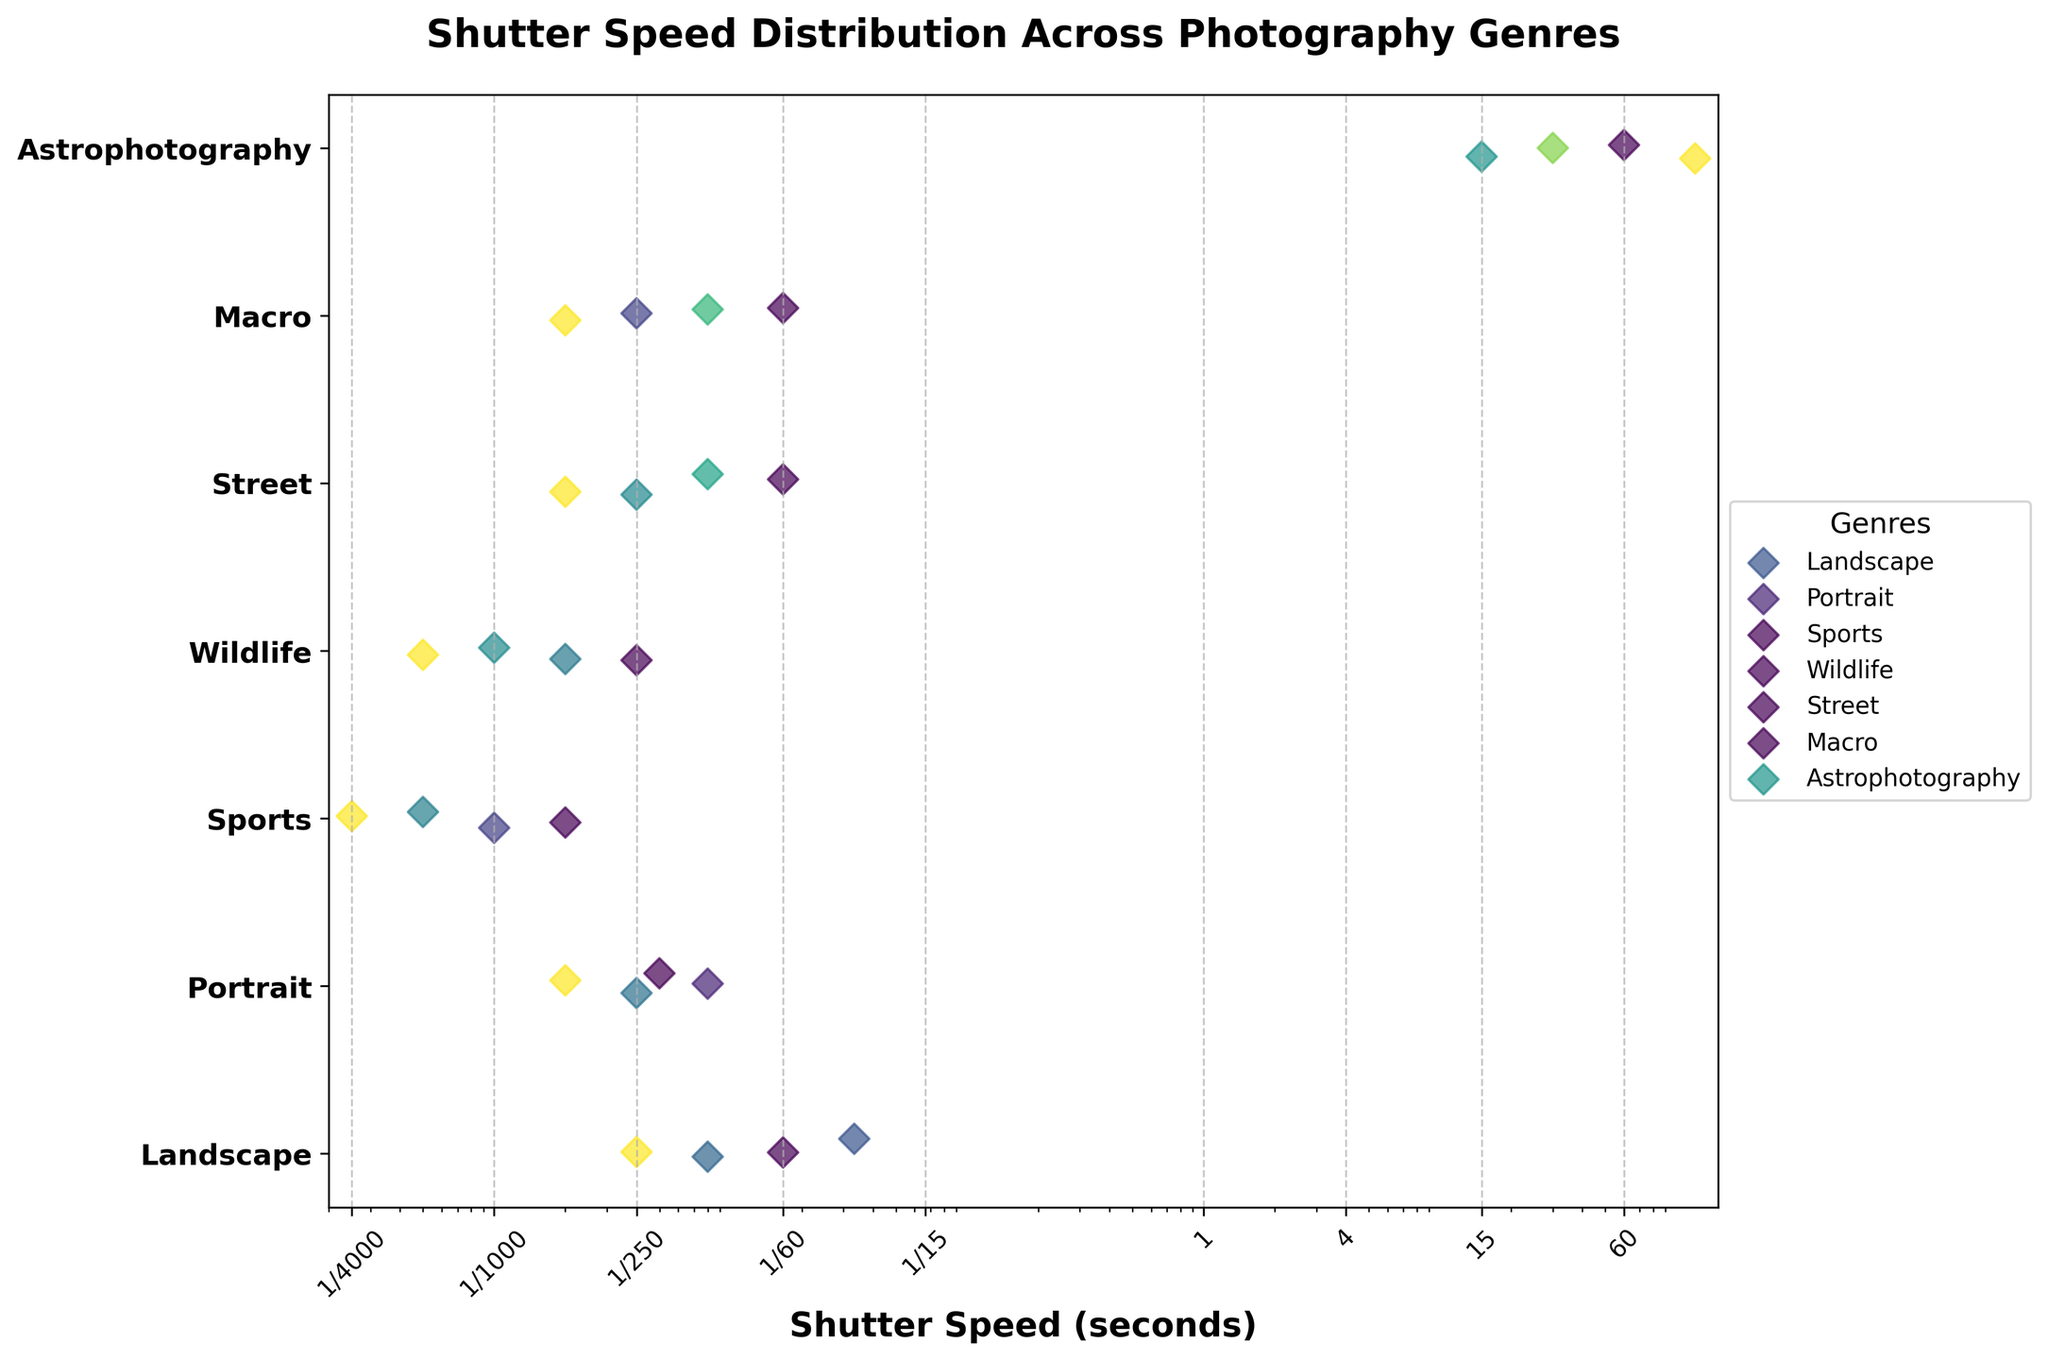What is the title of the plot? The title of the plot is usually displayed at the top of the figure. It provides an overview of what the plot is about. In this figure, the title is "Shutter Speed Distribution Across Photography Genres".
Answer: Shutter Speed Distribution Across Photography Genres How many photography genres are displayed in the figure? The number of photography genres can be determined by counting the unique y-axis labels. Each label corresponds to a different genre.
Answer: 7 What genre has the widest range of shutter speeds? By observing the plot, the range of shutter speeds can be seen as the distance covered by data points along the x-axis for each genre. The genre with data points spread out the most across the x-axis has the widest range.
Answer: Astrophotography Which genre generally uses the fastest shutter speeds? The fastest shutter speeds are the data points that are closest to the leftmost side of the log-scale x-axis. Compare the position of leftmost points for each genre to determine which genre uses the fastest shutter speeds.
Answer: Sports How does the average shutter speed for Portrait photography compare to that for Landscape photography? To determine this, compare the central clusters or average positions of the data points for Portrait and Landscape genres along the x-axis. Portrait photography has data points more to the right compared to Landscape photography, indicating generally slower shutter speeds.
Answer: Slower What is the slowest shutter speed used in Street photography? The slowest shutter speed for any genre is the rightmost data point on the x-axis for that specific genre. For Street photography, identify the rightmost data point.
Answer: 1/60 Which genre shows the most variation in shutter speeds, excluding Astrophotography? Besides Astrophotography, assess which genre has data points spread out the most across the x-axis.
Answer: Sports Which genre uses shutter speeds around 1 second or longer? Locate the section of the x-axis that corresponds to 1 second or longer, then identify which genres have data points within this range.
Answer: Astrophotography Are there any genres that do not use shutter speeds faster than 1/500? Fast shutter speeds are to the left of the x-axis around 1/500. Check if there are genres whose data points do not extend into the region left of 1/500.
Answer: Yes, Landscape and Astrophotography 